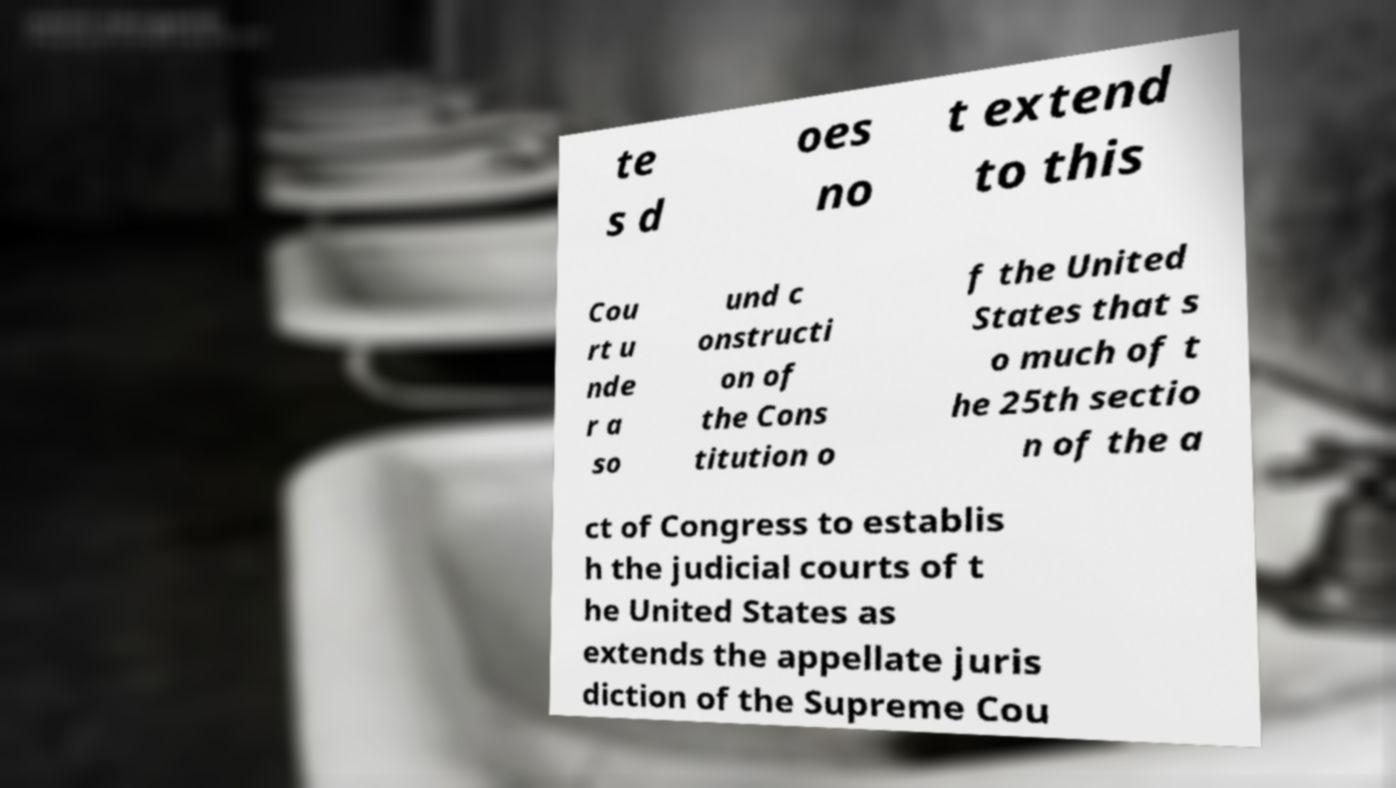Can you accurately transcribe the text from the provided image for me? te s d oes no t extend to this Cou rt u nde r a so und c onstructi on of the Cons titution o f the United States that s o much of t he 25th sectio n of the a ct of Congress to establis h the judicial courts of t he United States as extends the appellate juris diction of the Supreme Cou 